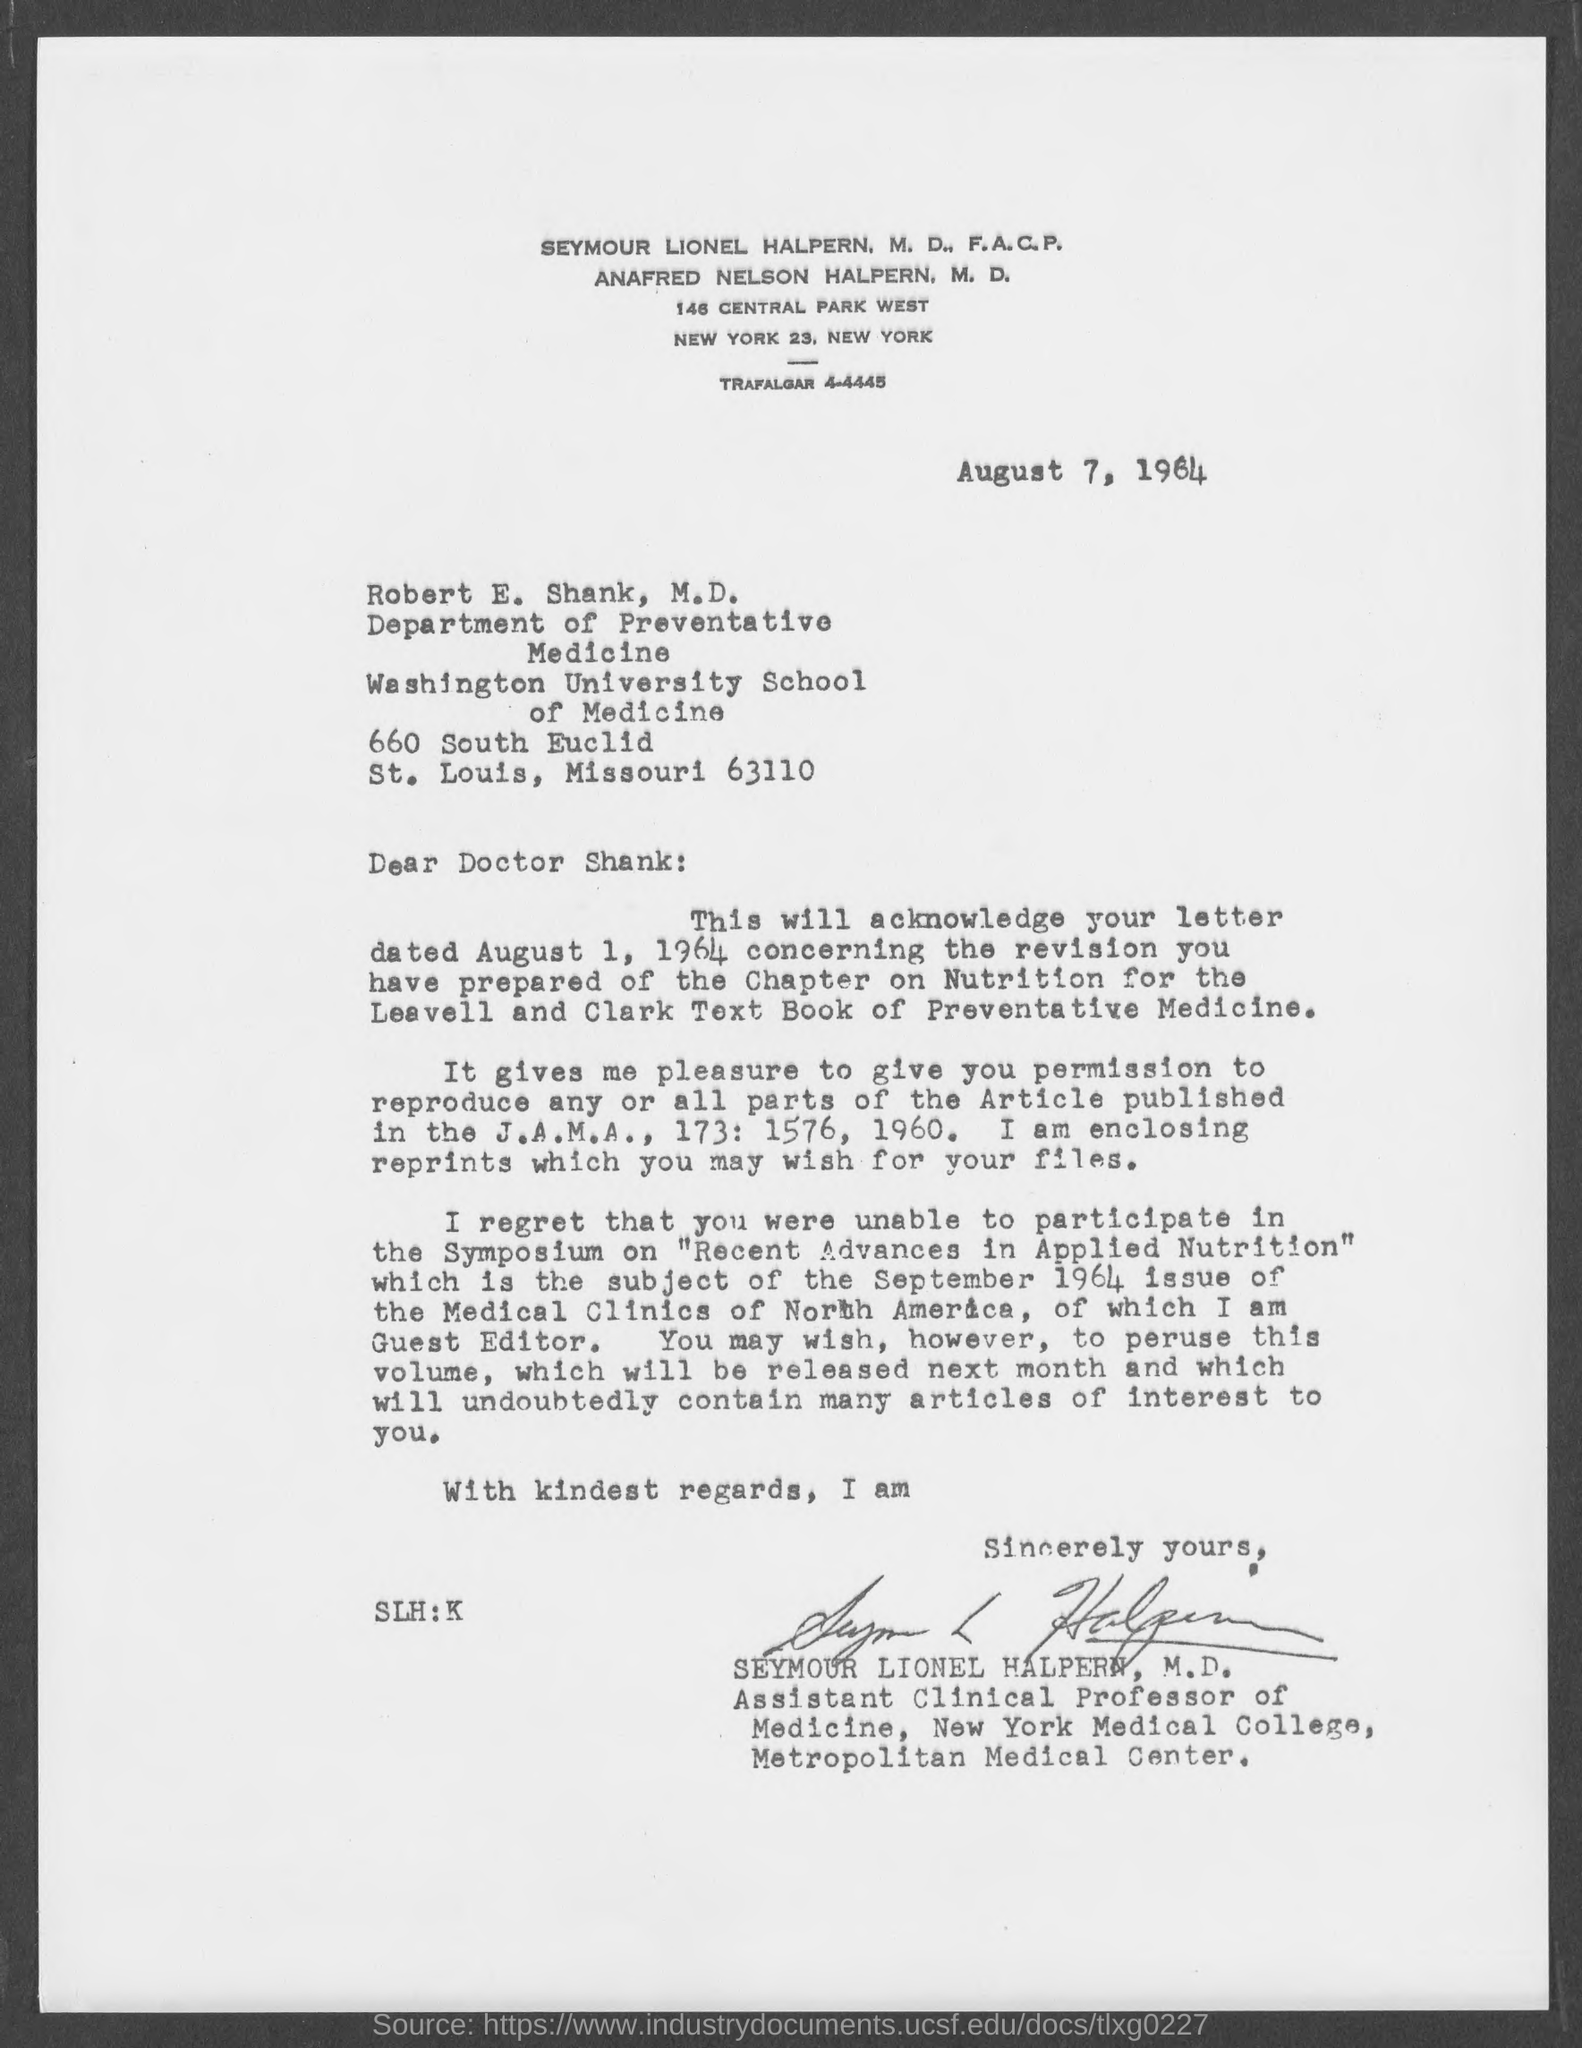Give some essential details in this illustration. The letter was written by Seymour Lionel Halpern, M.D. 